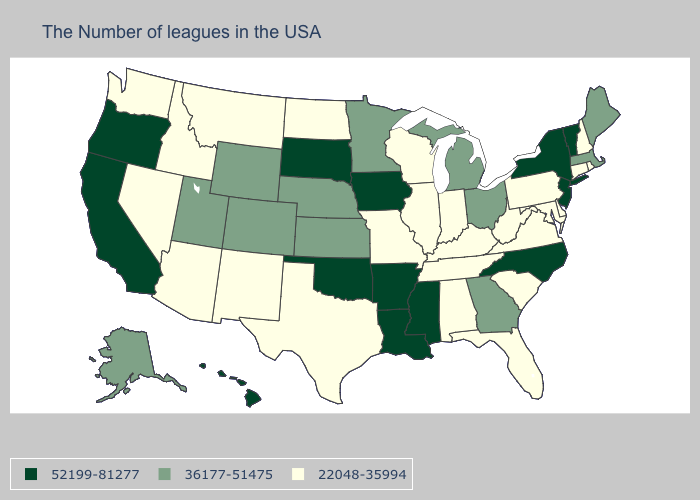What is the value of Kentucky?
Answer briefly. 22048-35994. Which states have the lowest value in the USA?
Concise answer only. Rhode Island, New Hampshire, Connecticut, Delaware, Maryland, Pennsylvania, Virginia, South Carolina, West Virginia, Florida, Kentucky, Indiana, Alabama, Tennessee, Wisconsin, Illinois, Missouri, Texas, North Dakota, New Mexico, Montana, Arizona, Idaho, Nevada, Washington. Name the states that have a value in the range 36177-51475?
Give a very brief answer. Maine, Massachusetts, Ohio, Georgia, Michigan, Minnesota, Kansas, Nebraska, Wyoming, Colorado, Utah, Alaska. What is the value of Ohio?
Give a very brief answer. 36177-51475. Which states hav the highest value in the West?
Short answer required. California, Oregon, Hawaii. What is the highest value in states that border Indiana?
Short answer required. 36177-51475. Does the first symbol in the legend represent the smallest category?
Give a very brief answer. No. What is the lowest value in states that border Maryland?
Quick response, please. 22048-35994. What is the value of Louisiana?
Write a very short answer. 52199-81277. Does Florida have the lowest value in the South?
Concise answer only. Yes. Name the states that have a value in the range 52199-81277?
Give a very brief answer. Vermont, New York, New Jersey, North Carolina, Mississippi, Louisiana, Arkansas, Iowa, Oklahoma, South Dakota, California, Oregon, Hawaii. Is the legend a continuous bar?
Keep it brief. No. What is the value of Oregon?
Answer briefly. 52199-81277. Name the states that have a value in the range 36177-51475?
Give a very brief answer. Maine, Massachusetts, Ohio, Georgia, Michigan, Minnesota, Kansas, Nebraska, Wyoming, Colorado, Utah, Alaska. Does Nebraska have the same value as Maine?
Concise answer only. Yes. 